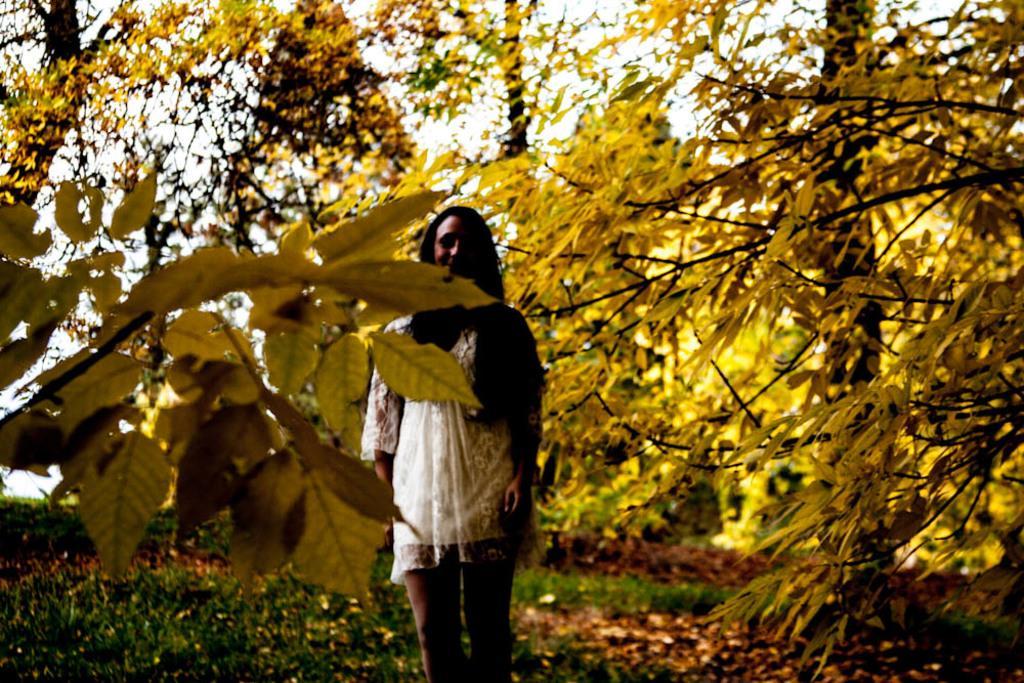In one or two sentences, can you explain what this image depicts? In this image we can see a woman and she is smiling. Here we can see plants, dried leaves, and trees. In the background there is sky. 